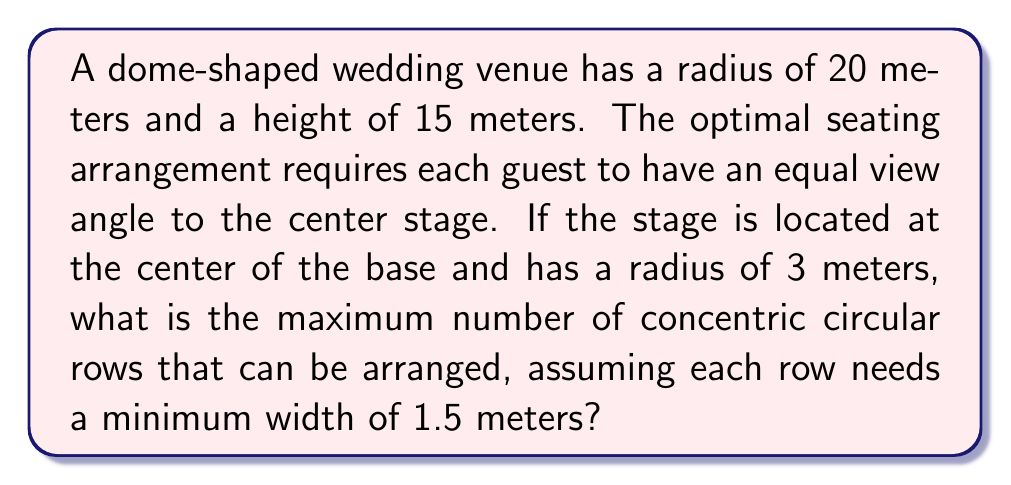Provide a solution to this math problem. Let's approach this step-by-step:

1) First, we need to understand the geometry of the dome. It can be modeled as a spherical cap. The equation of a sphere is:

   $$x^2 + y^2 + z^2 = R^2$$

   where $R$ is the radius of the sphere.

2) We can find $R$ using the Pythagorean theorem:

   $$R^2 = r^2 + (R-h)^2$$

   where $r = 20$ (radius of the base) and $h = 15$ (height of the dome).

3) Solving this equation:

   $$R^2 = 20^2 + (R-15)^2$$
   $$R^2 = 400 + R^2 - 30R + 225$$
   $$30R = 625$$
   $$R = \frac{625}{30} \approx 20.83$$

4) Now, to ensure an equal view angle, the seats should be arranged along the surface of concentric spheres centered at the top of the stage.

5) The distance from the center of the base to the edge of the stage is 3 meters. The available space for seating is from 3 meters to 20 meters (the radius of the base).

6) The arc length on the sphere surface between two rows should be at least 1.5 meters. We can calculate the central angle $\theta$ for this arc length:

   $$\theta = \frac{1.5}{R} = \frac{1.5}{20.83} \approx 0.072 \text{ radians}$$

7) Now, we need to find how many of these angles fit between the edge of the stage and the edge of the dome. The angle from the center of the sphere to the edge of the stage is:

   $$\theta_1 = \arcsin(\frac{3}{20.83}) \approx 0.144 \text{ radians}$$

   And to the edge of the base:

   $$\theta_2 = \arcsin(\frac{20}{20.83}) \approx 1.373 \text{ radians}$$

8) The available angle is $\theta_2 - \theta_1 \approx 1.229 \text{ radians}$

9) The number of rows that can fit is:

   $$\frac{1.229}{0.072} \approx 17.07$$

Therefore, the maximum number of concentric circular rows is 17.
Answer: 17 rows 